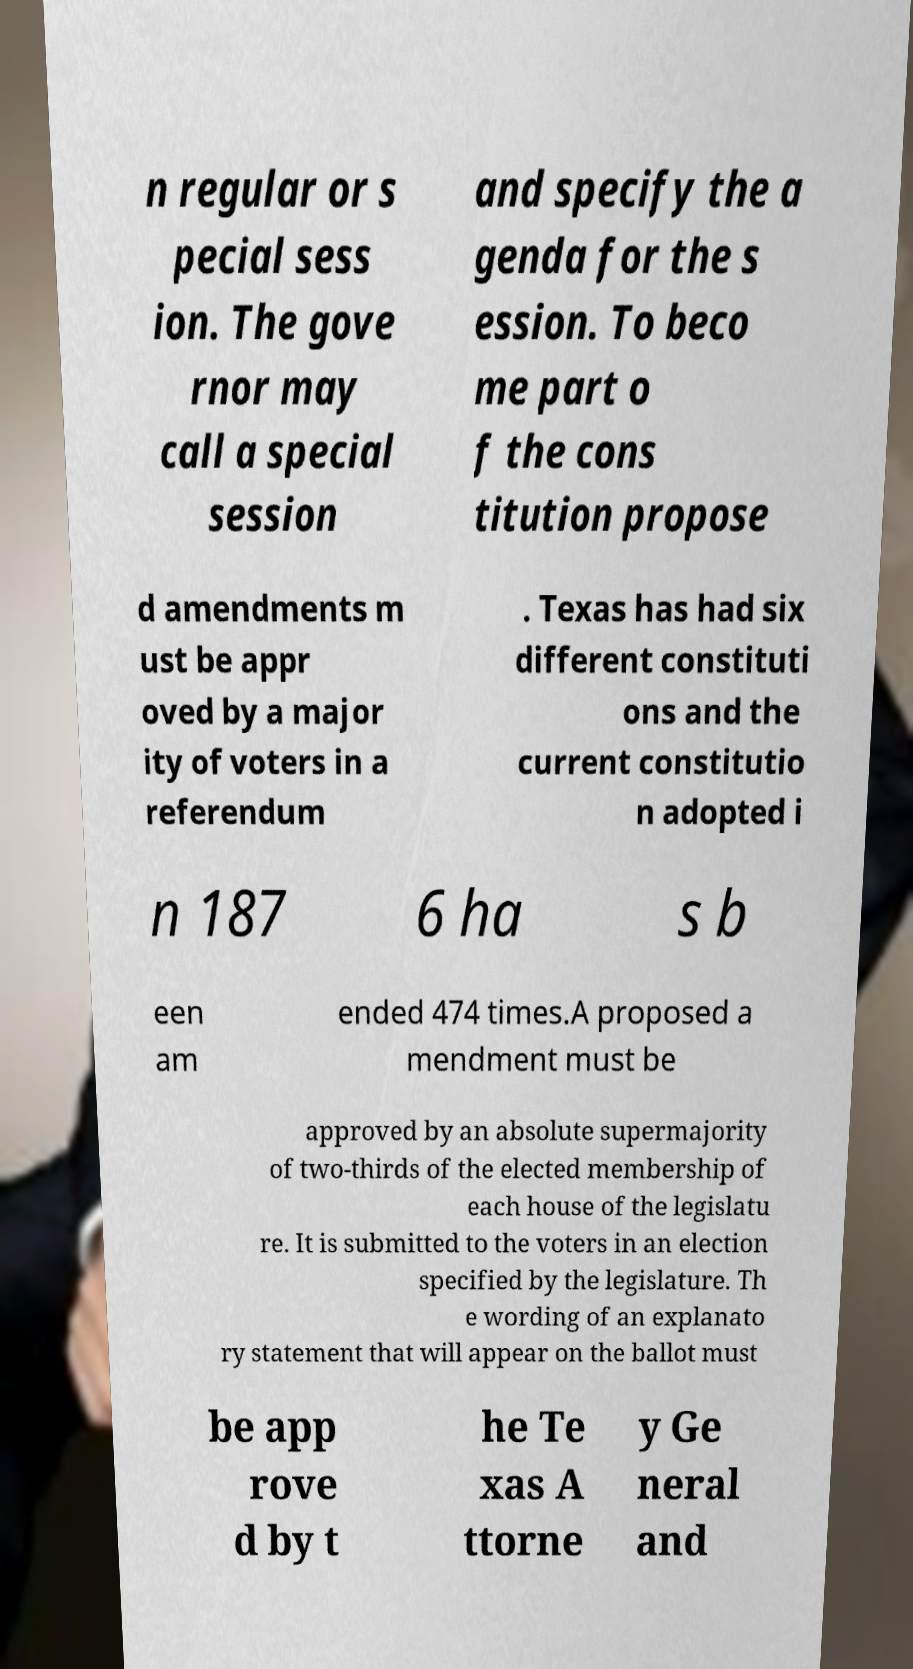Can you read and provide the text displayed in the image?This photo seems to have some interesting text. Can you extract and type it out for me? n regular or s pecial sess ion. The gove rnor may call a special session and specify the a genda for the s ession. To beco me part o f the cons titution propose d amendments m ust be appr oved by a major ity of voters in a referendum . Texas has had six different constituti ons and the current constitutio n adopted i n 187 6 ha s b een am ended 474 times.A proposed a mendment must be approved by an absolute supermajority of two-thirds of the elected membership of each house of the legislatu re. It is submitted to the voters in an election specified by the legislature. Th e wording of an explanato ry statement that will appear on the ballot must be app rove d by t he Te xas A ttorne y Ge neral and 